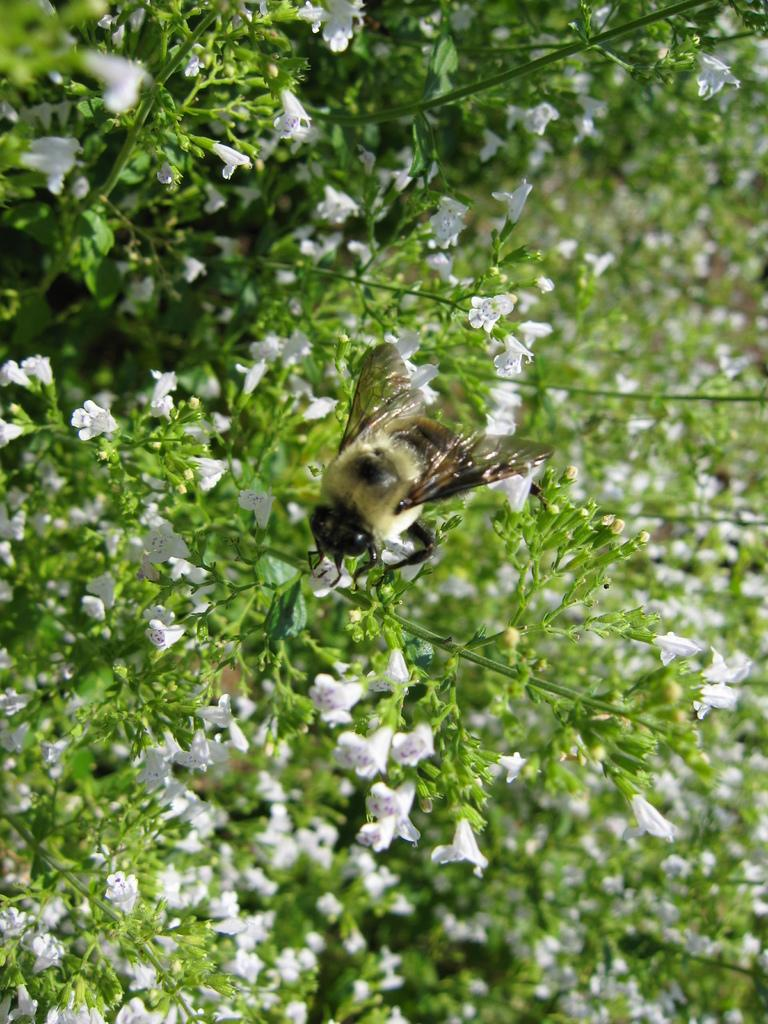What is on the plant in the image? There is a bee on a plant in the image. What can be found on the plants in the image? There are flowers on the plants in the image. What type of pipe is visible in the image? There is no pipe present in the image. Are there any dinosaurs visible in the image? There are no dinosaurs present in the image. 